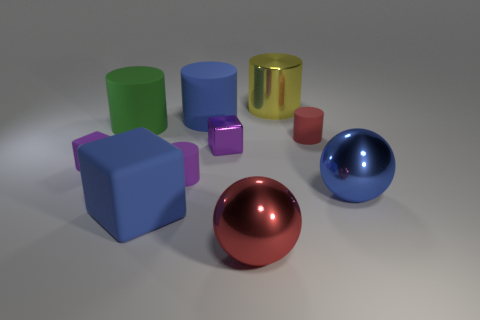Subtract all red matte cylinders. How many cylinders are left? 4 Subtract all cubes. How many objects are left? 7 Subtract all cyan cylinders. How many blue spheres are left? 1 Subtract all green cylinders. Subtract all large yellow metallic cubes. How many objects are left? 9 Add 8 red cylinders. How many red cylinders are left? 9 Add 6 large blue shiny balls. How many large blue shiny balls exist? 7 Subtract all blue cubes. How many cubes are left? 2 Subtract 0 green balls. How many objects are left? 10 Subtract 2 cylinders. How many cylinders are left? 3 Subtract all brown cubes. Subtract all green spheres. How many cubes are left? 3 